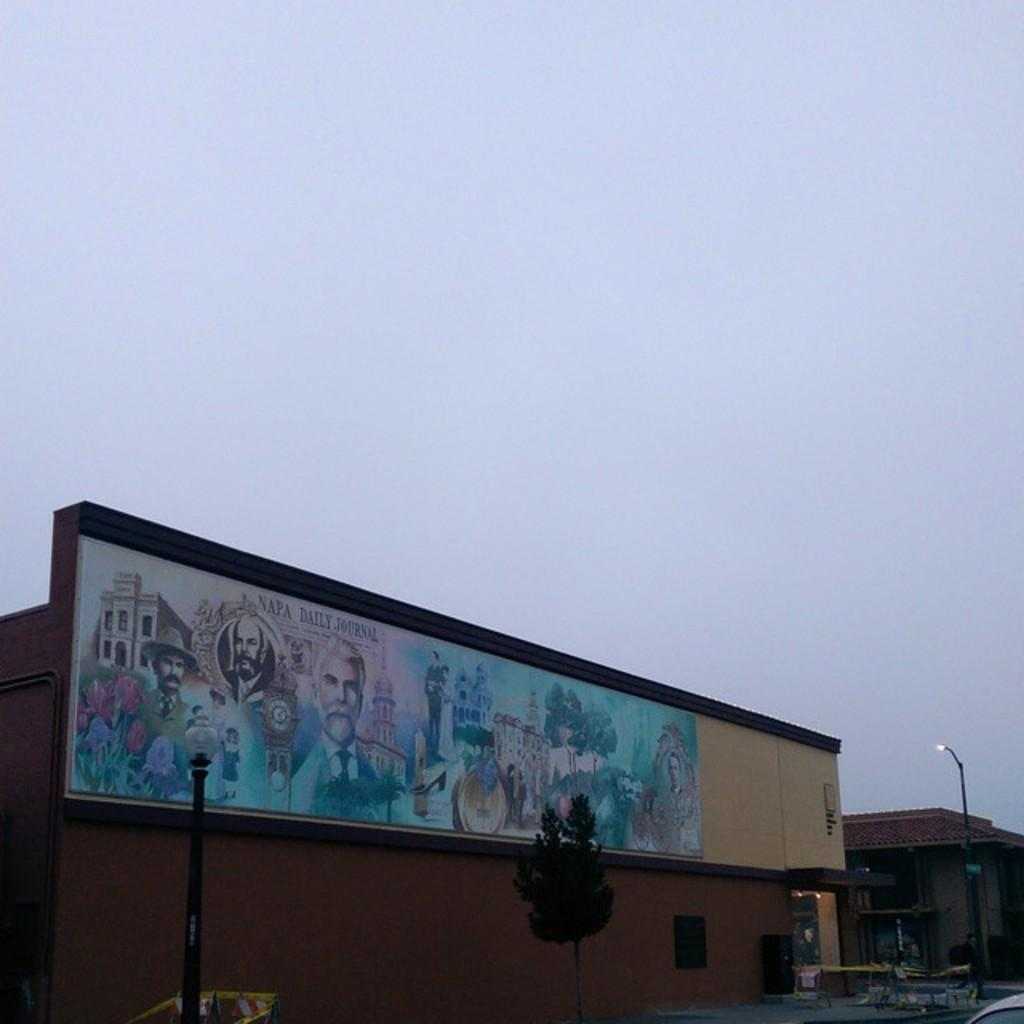<image>
Provide a brief description of the given image. The mural on the side of the building commemorates the Napa Daily Journal 